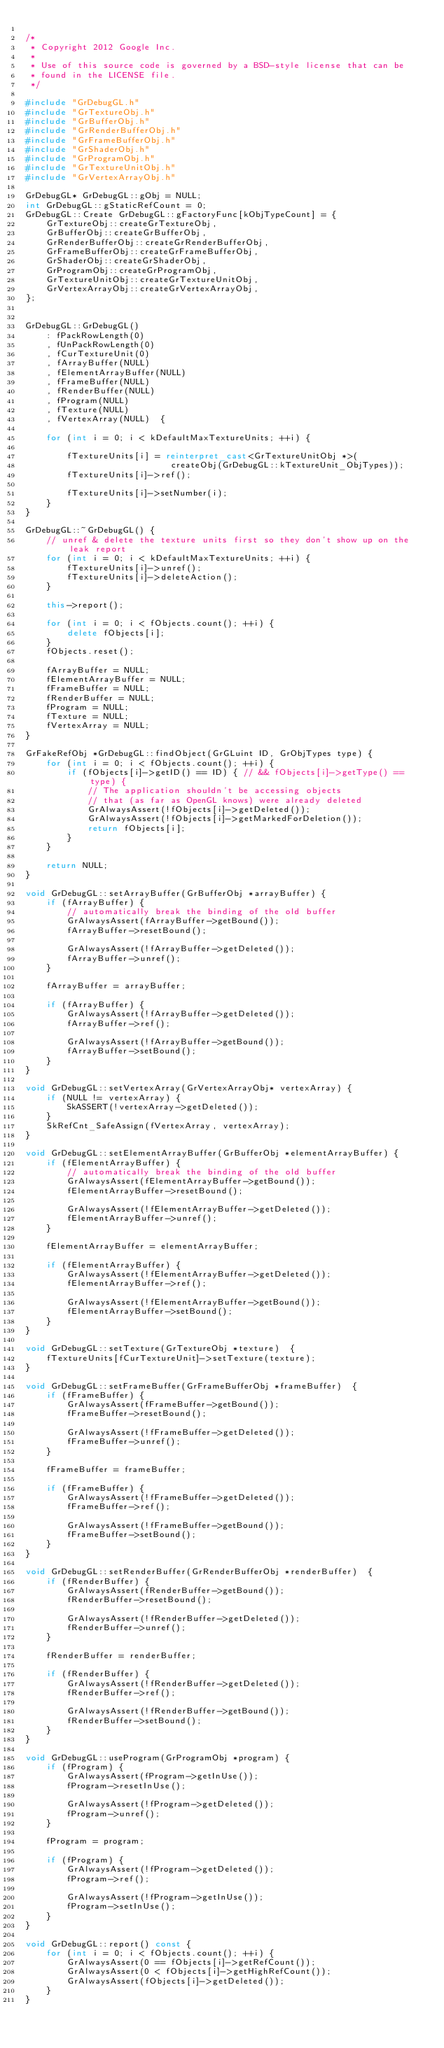<code> <loc_0><loc_0><loc_500><loc_500><_C++_>
/*
 * Copyright 2012 Google Inc.
 *
 * Use of this source code is governed by a BSD-style license that can be
 * found in the LICENSE file.
 */

#include "GrDebugGL.h"
#include "GrTextureObj.h"
#include "GrBufferObj.h"
#include "GrRenderBufferObj.h"
#include "GrFrameBufferObj.h"
#include "GrShaderObj.h"
#include "GrProgramObj.h"
#include "GrTextureUnitObj.h"
#include "GrVertexArrayObj.h"

GrDebugGL* GrDebugGL::gObj = NULL;
int GrDebugGL::gStaticRefCount = 0;
GrDebugGL::Create GrDebugGL::gFactoryFunc[kObjTypeCount] = {
    GrTextureObj::createGrTextureObj,
    GrBufferObj::createGrBufferObj,
    GrRenderBufferObj::createGrRenderBufferObj,
    GrFrameBufferObj::createGrFrameBufferObj,
    GrShaderObj::createGrShaderObj,
    GrProgramObj::createGrProgramObj,
    GrTextureUnitObj::createGrTextureUnitObj,
    GrVertexArrayObj::createGrVertexArrayObj,
};


GrDebugGL::GrDebugGL()
    : fPackRowLength(0)
    , fUnPackRowLength(0)
    , fCurTextureUnit(0)
    , fArrayBuffer(NULL)
    , fElementArrayBuffer(NULL)
    , fFrameBuffer(NULL)
    , fRenderBuffer(NULL)
    , fProgram(NULL)
    , fTexture(NULL)
    , fVertexArray(NULL)  {

    for (int i = 0; i < kDefaultMaxTextureUnits; ++i) {

        fTextureUnits[i] = reinterpret_cast<GrTextureUnitObj *>(
                            createObj(GrDebugGL::kTextureUnit_ObjTypes));
        fTextureUnits[i]->ref();

        fTextureUnits[i]->setNumber(i);
    }
}

GrDebugGL::~GrDebugGL() {
    // unref & delete the texture units first so they don't show up on the leak report
    for (int i = 0; i < kDefaultMaxTextureUnits; ++i) {
        fTextureUnits[i]->unref();
        fTextureUnits[i]->deleteAction();
    }

    this->report();

    for (int i = 0; i < fObjects.count(); ++i) {
        delete fObjects[i];
    }
    fObjects.reset();

    fArrayBuffer = NULL;
    fElementArrayBuffer = NULL;
    fFrameBuffer = NULL;
    fRenderBuffer = NULL;
    fProgram = NULL;
    fTexture = NULL;
    fVertexArray = NULL;
}

GrFakeRefObj *GrDebugGL::findObject(GrGLuint ID, GrObjTypes type) {
    for (int i = 0; i < fObjects.count(); ++i) {
        if (fObjects[i]->getID() == ID) { // && fObjects[i]->getType() == type) {
            // The application shouldn't be accessing objects
            // that (as far as OpenGL knows) were already deleted
            GrAlwaysAssert(!fObjects[i]->getDeleted());
            GrAlwaysAssert(!fObjects[i]->getMarkedForDeletion());
            return fObjects[i];
        }
    }

    return NULL;
}

void GrDebugGL::setArrayBuffer(GrBufferObj *arrayBuffer) {
    if (fArrayBuffer) {
        // automatically break the binding of the old buffer
        GrAlwaysAssert(fArrayBuffer->getBound());
        fArrayBuffer->resetBound();

        GrAlwaysAssert(!fArrayBuffer->getDeleted());
        fArrayBuffer->unref();
    }

    fArrayBuffer = arrayBuffer;

    if (fArrayBuffer) {
        GrAlwaysAssert(!fArrayBuffer->getDeleted());
        fArrayBuffer->ref();

        GrAlwaysAssert(!fArrayBuffer->getBound());
        fArrayBuffer->setBound();
    }
}

void GrDebugGL::setVertexArray(GrVertexArrayObj* vertexArray) {
    if (NULL != vertexArray) {
        SkASSERT(!vertexArray->getDeleted());
    }
    SkRefCnt_SafeAssign(fVertexArray, vertexArray);
}

void GrDebugGL::setElementArrayBuffer(GrBufferObj *elementArrayBuffer) {
    if (fElementArrayBuffer) {
        // automatically break the binding of the old buffer
        GrAlwaysAssert(fElementArrayBuffer->getBound());
        fElementArrayBuffer->resetBound();

        GrAlwaysAssert(!fElementArrayBuffer->getDeleted());
        fElementArrayBuffer->unref();
    }

    fElementArrayBuffer = elementArrayBuffer;

    if (fElementArrayBuffer) {
        GrAlwaysAssert(!fElementArrayBuffer->getDeleted());
        fElementArrayBuffer->ref();

        GrAlwaysAssert(!fElementArrayBuffer->getBound());
        fElementArrayBuffer->setBound();
    }
}

void GrDebugGL::setTexture(GrTextureObj *texture)  {
    fTextureUnits[fCurTextureUnit]->setTexture(texture);
}

void GrDebugGL::setFrameBuffer(GrFrameBufferObj *frameBuffer)  {
    if (fFrameBuffer) {
        GrAlwaysAssert(fFrameBuffer->getBound());
        fFrameBuffer->resetBound();

        GrAlwaysAssert(!fFrameBuffer->getDeleted());
        fFrameBuffer->unref();
    }

    fFrameBuffer = frameBuffer;

    if (fFrameBuffer) {
        GrAlwaysAssert(!fFrameBuffer->getDeleted());
        fFrameBuffer->ref();

        GrAlwaysAssert(!fFrameBuffer->getBound());
        fFrameBuffer->setBound();
    }
}

void GrDebugGL::setRenderBuffer(GrRenderBufferObj *renderBuffer)  {
    if (fRenderBuffer) {
        GrAlwaysAssert(fRenderBuffer->getBound());
        fRenderBuffer->resetBound();

        GrAlwaysAssert(!fRenderBuffer->getDeleted());
        fRenderBuffer->unref();
    }

    fRenderBuffer = renderBuffer;

    if (fRenderBuffer) {
        GrAlwaysAssert(!fRenderBuffer->getDeleted());
        fRenderBuffer->ref();

        GrAlwaysAssert(!fRenderBuffer->getBound());
        fRenderBuffer->setBound();
    }
}

void GrDebugGL::useProgram(GrProgramObj *program) {
    if (fProgram) {
        GrAlwaysAssert(fProgram->getInUse());
        fProgram->resetInUse();

        GrAlwaysAssert(!fProgram->getDeleted());
        fProgram->unref();
    }

    fProgram = program;

    if (fProgram) {
        GrAlwaysAssert(!fProgram->getDeleted());
        fProgram->ref();

        GrAlwaysAssert(!fProgram->getInUse());
        fProgram->setInUse();
    }
}

void GrDebugGL::report() const {
    for (int i = 0; i < fObjects.count(); ++i) {
        GrAlwaysAssert(0 == fObjects[i]->getRefCount());
        GrAlwaysAssert(0 < fObjects[i]->getHighRefCount());
        GrAlwaysAssert(fObjects[i]->getDeleted());
    }
}
</code> 